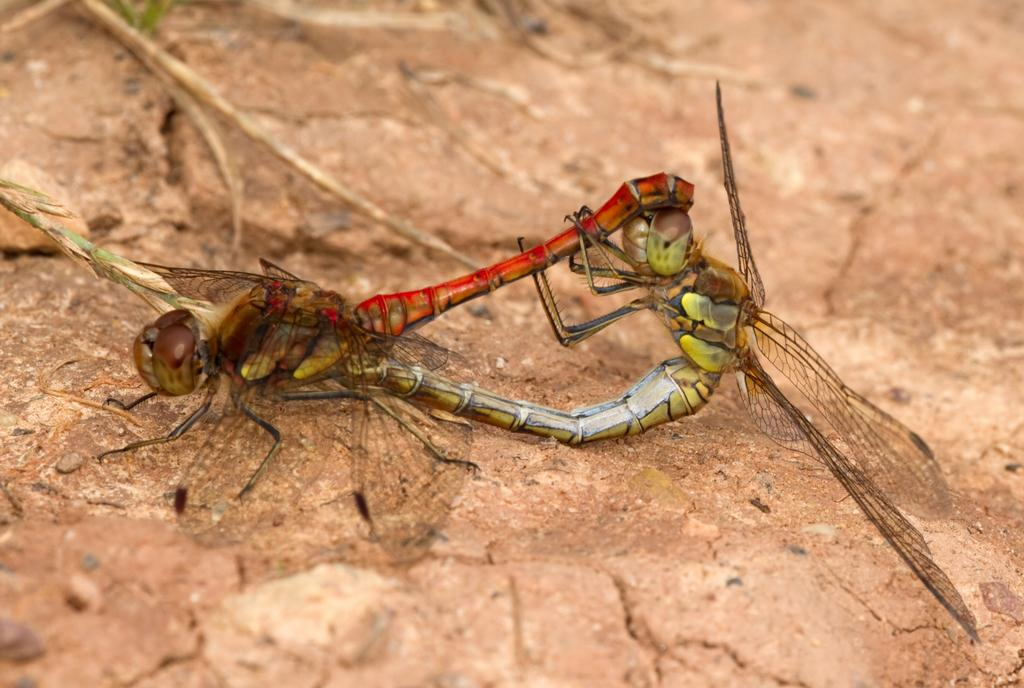What type of insects are present in the image? There are dragonflies in the image. Where are the dragonflies located? The dragonflies are on a stone surface. What type of bag can be seen in the image? There is no bag present in the image; it features dragonflies on a stone surface. What emotion do the dragonflies appear to be experiencing in the image? The image does not convey emotions, as dragonflies are insects and do not have the ability to express emotions like fear. 